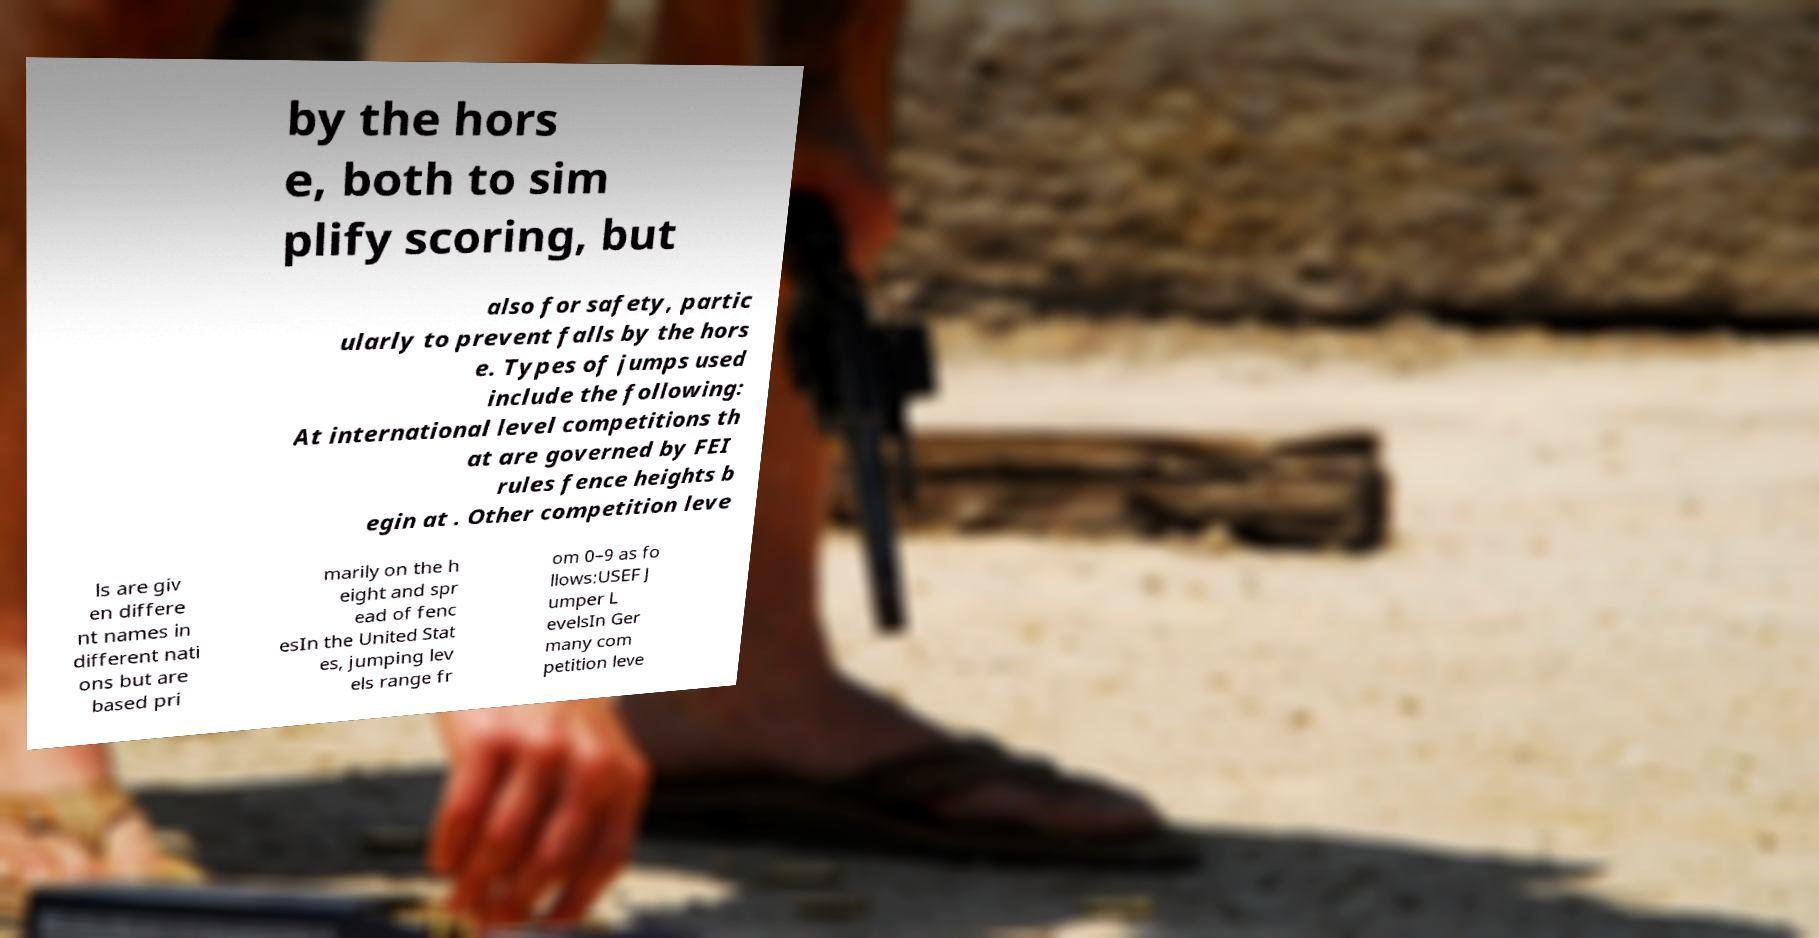For documentation purposes, I need the text within this image transcribed. Could you provide that? by the hors e, both to sim plify scoring, but also for safety, partic ularly to prevent falls by the hors e. Types of jumps used include the following: At international level competitions th at are governed by FEI rules fence heights b egin at . Other competition leve ls are giv en differe nt names in different nati ons but are based pri marily on the h eight and spr ead of fenc esIn the United Stat es, jumping lev els range fr om 0–9 as fo llows:USEF J umper L evelsIn Ger many com petition leve 